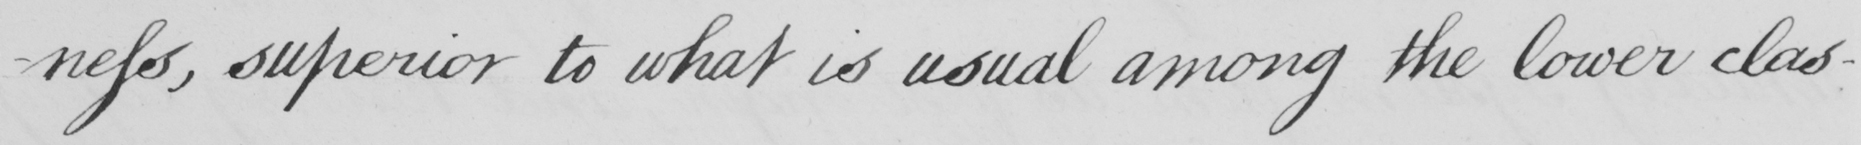What text is written in this handwritten line? -ness, superior to what is usual among the lower clas- 